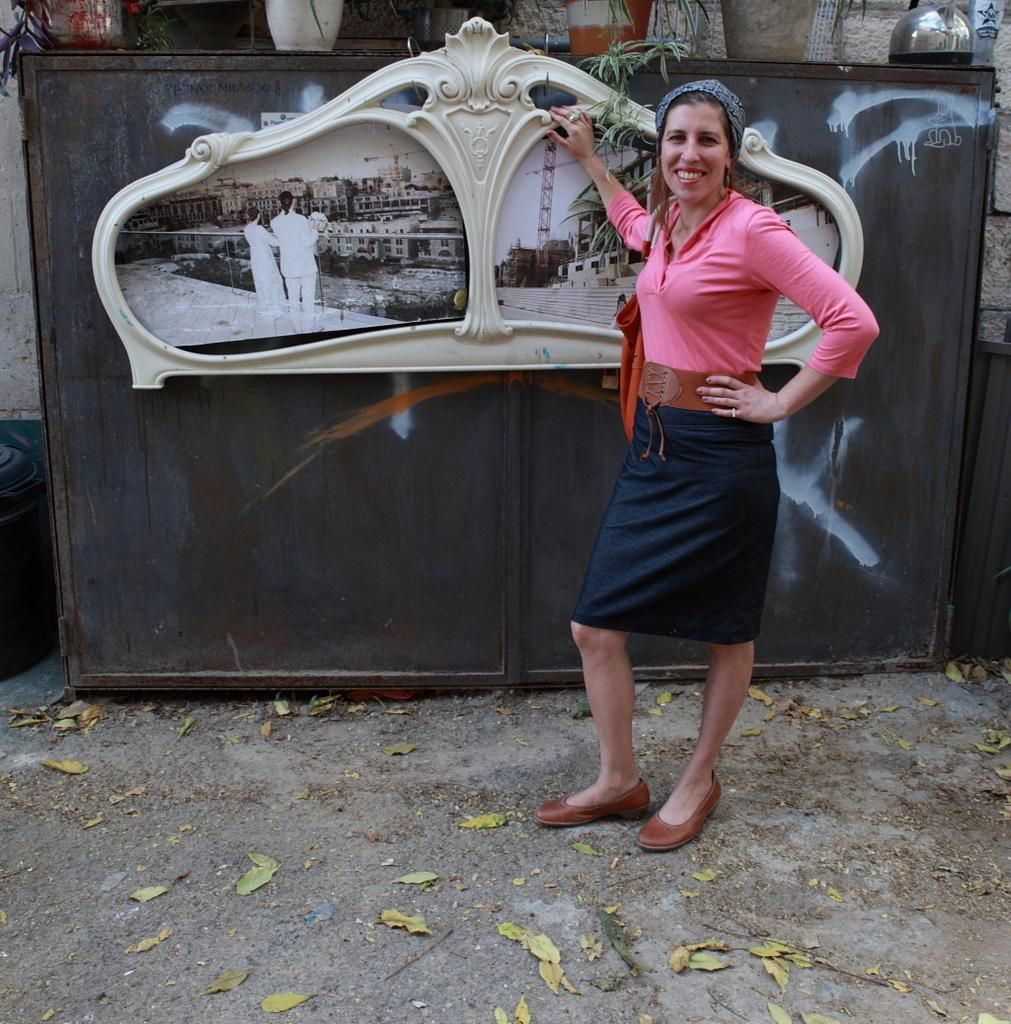What is the woman in the image doing? The woman is standing on the ground and smiling in the image. What can be seen in the background or surrounding the woman? There are house plants and photos in the image. What is depicted in the photos? The photos contain images of steps, buildings, and two persons standing at a fence. What type of bean is being used as a prop in the image? There is no bean present in the image. What invention is the woman holding in the image? The woman is not holding any invention in the image. 